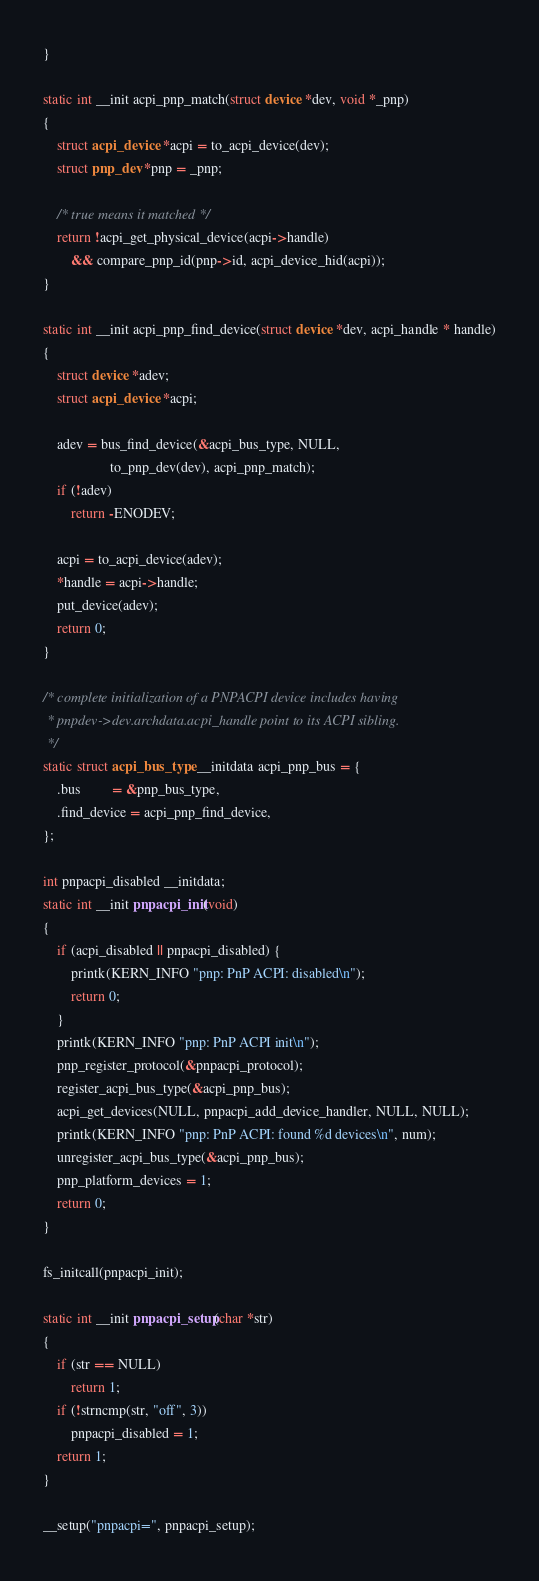<code> <loc_0><loc_0><loc_500><loc_500><_C_>}

static int __init acpi_pnp_match(struct device *dev, void *_pnp)
{
	struct acpi_device *acpi = to_acpi_device(dev);
	struct pnp_dev *pnp = _pnp;

	/* true means it matched */
	return !acpi_get_physical_device(acpi->handle)
	    && compare_pnp_id(pnp->id, acpi_device_hid(acpi));
}

static int __init acpi_pnp_find_device(struct device *dev, acpi_handle * handle)
{
	struct device *adev;
	struct acpi_device *acpi;

	adev = bus_find_device(&acpi_bus_type, NULL,
			       to_pnp_dev(dev), acpi_pnp_match);
	if (!adev)
		return -ENODEV;

	acpi = to_acpi_device(adev);
	*handle = acpi->handle;
	put_device(adev);
	return 0;
}

/* complete initialization of a PNPACPI device includes having
 * pnpdev->dev.archdata.acpi_handle point to its ACPI sibling.
 */
static struct acpi_bus_type __initdata acpi_pnp_bus = {
	.bus	     = &pnp_bus_type,
	.find_device = acpi_pnp_find_device,
};

int pnpacpi_disabled __initdata;
static int __init pnpacpi_init(void)
{
	if (acpi_disabled || pnpacpi_disabled) {
		printk(KERN_INFO "pnp: PnP ACPI: disabled\n");
		return 0;
	}
	printk(KERN_INFO "pnp: PnP ACPI init\n");
	pnp_register_protocol(&pnpacpi_protocol);
	register_acpi_bus_type(&acpi_pnp_bus);
	acpi_get_devices(NULL, pnpacpi_add_device_handler, NULL, NULL);
	printk(KERN_INFO "pnp: PnP ACPI: found %d devices\n", num);
	unregister_acpi_bus_type(&acpi_pnp_bus);
	pnp_platform_devices = 1;
	return 0;
}

fs_initcall(pnpacpi_init);

static int __init pnpacpi_setup(char *str)
{
	if (str == NULL)
		return 1;
	if (!strncmp(str, "off", 3))
		pnpacpi_disabled = 1;
	return 1;
}

__setup("pnpacpi=", pnpacpi_setup);
</code> 